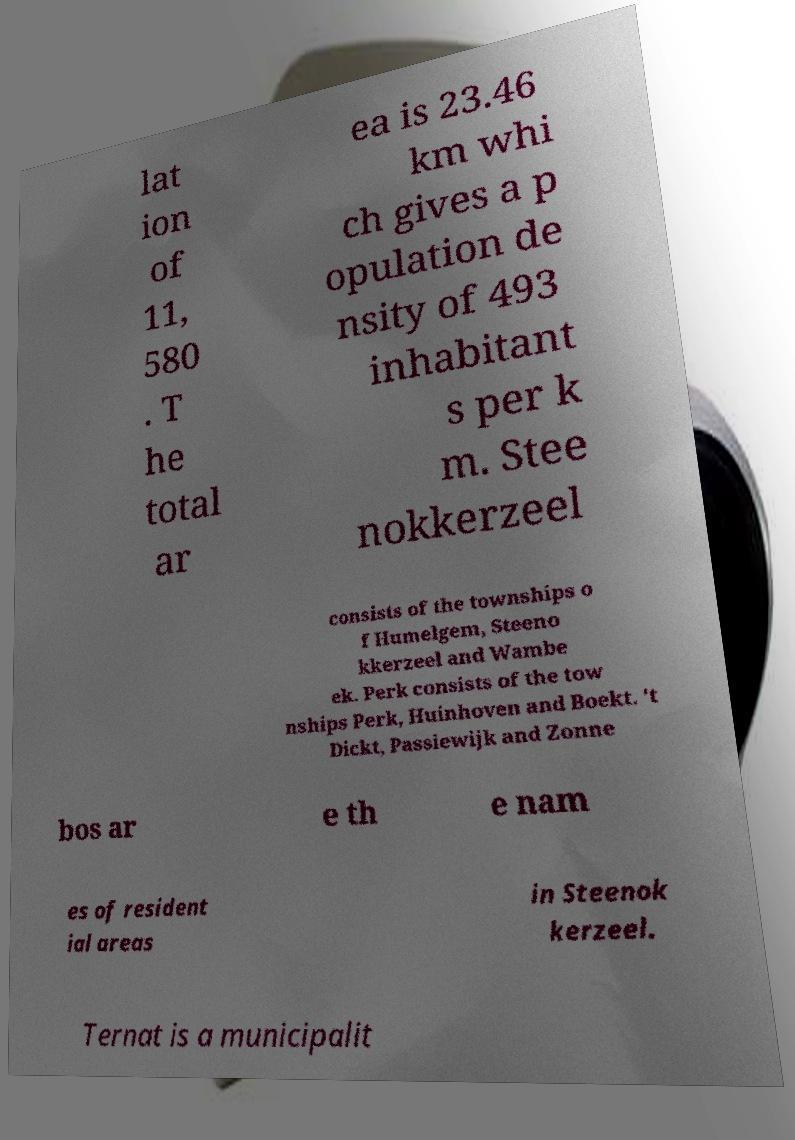Please read and relay the text visible in this image. What does it say? lat ion of 11, 580 . T he total ar ea is 23.46 km whi ch gives a p opulation de nsity of 493 inhabitant s per k m. Stee nokkerzeel consists of the townships o f Humelgem, Steeno kkerzeel and Wambe ek. Perk consists of the tow nships Perk, Huinhoven and Boekt. 't Dickt, Passiewijk and Zonne bos ar e th e nam es of resident ial areas in Steenok kerzeel. Ternat is a municipalit 